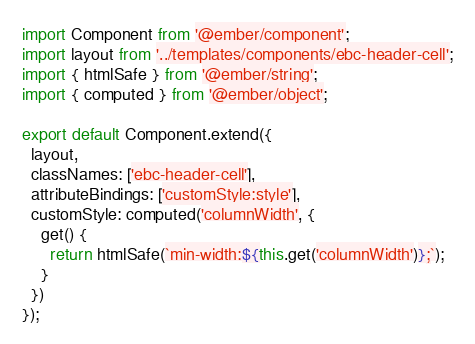Convert code to text. <code><loc_0><loc_0><loc_500><loc_500><_JavaScript_>import Component from '@ember/component';
import layout from '../templates/components/ebc-header-cell';
import { htmlSafe } from '@ember/string';
import { computed } from '@ember/object';

export default Component.extend({
  layout,
  classNames: ['ebc-header-cell'],
  attributeBindings: ['customStyle:style'],
  customStyle: computed('columnWidth', {
    get() {
      return htmlSafe(`min-width:${this.get('columnWidth')};`);
    }
  })
});
</code> 